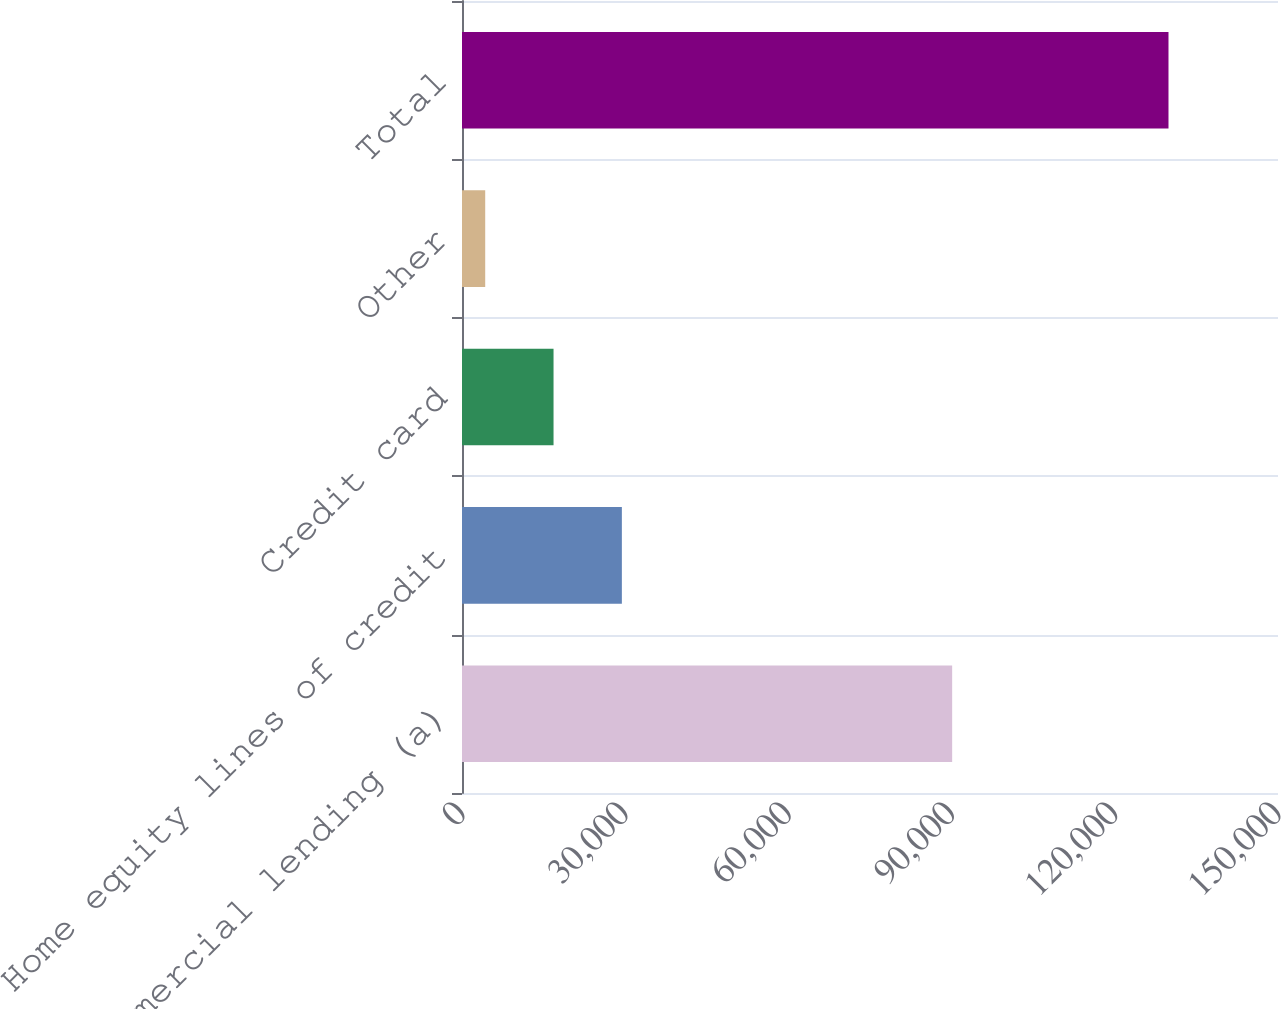Convert chart to OTSL. <chart><loc_0><loc_0><loc_500><loc_500><bar_chart><fcel>Total commercial lending (a)<fcel>Home equity lines of credit<fcel>Credit card<fcel>Other<fcel>Total<nl><fcel>90104<fcel>29386.8<fcel>16826.4<fcel>4266<fcel>129870<nl></chart> 